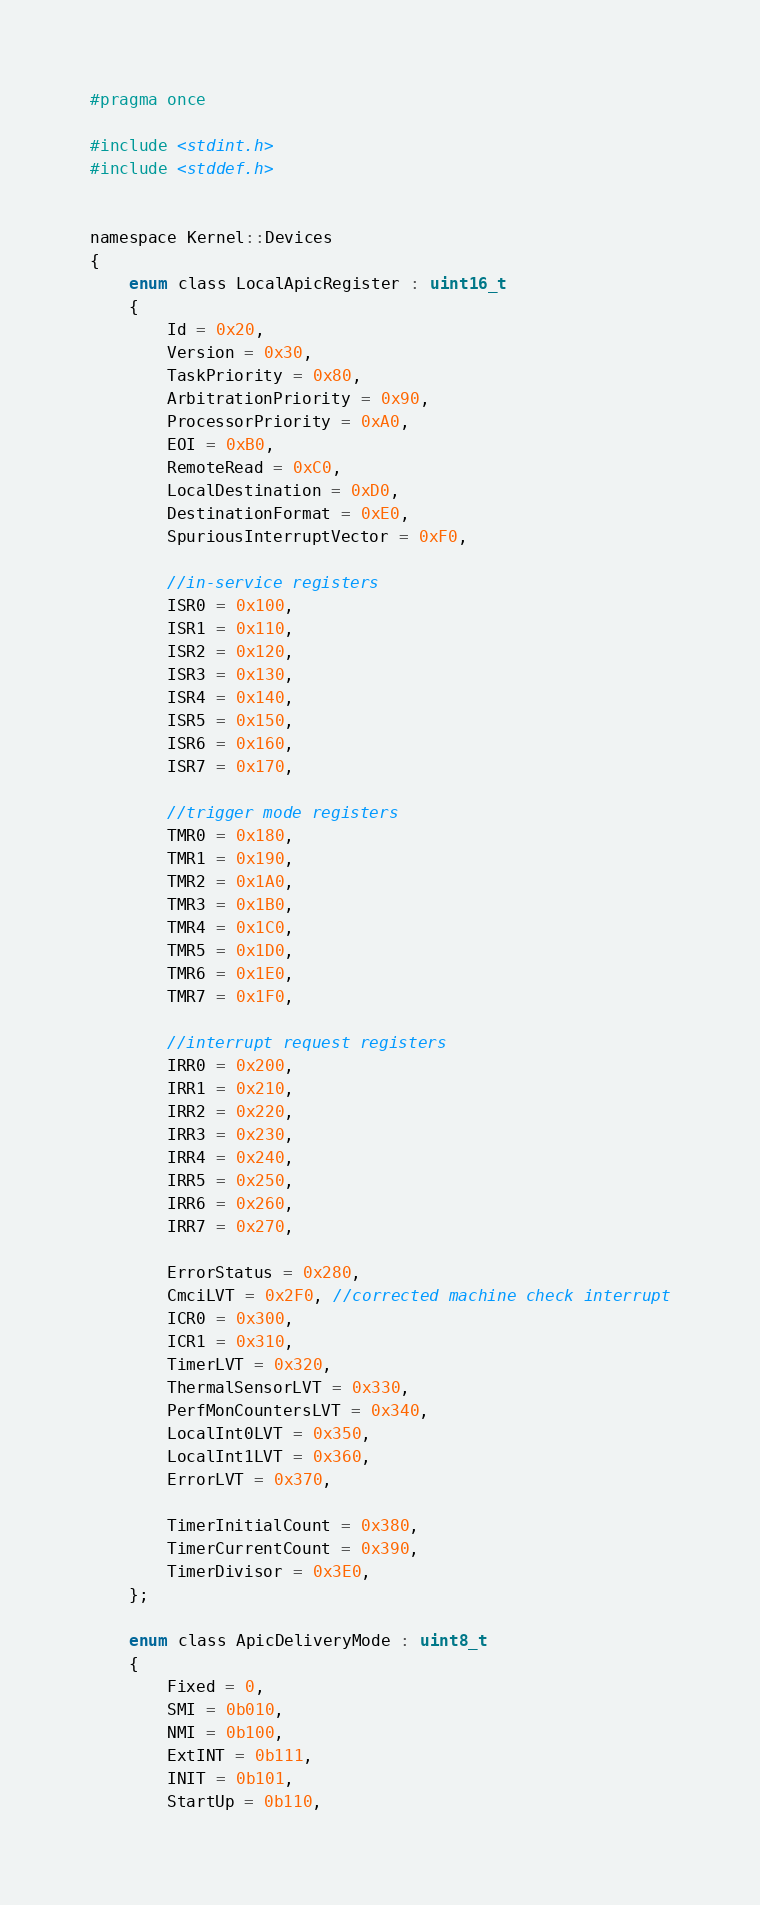Convert code to text. <code><loc_0><loc_0><loc_500><loc_500><_C_>#pragma once

#include <stdint.h>
#include <stddef.h>


namespace Kernel::Devices
{
    enum class LocalApicRegister : uint16_t
    {
        Id = 0x20,
        Version = 0x30,
        TaskPriority = 0x80,
        ArbitrationPriority = 0x90,
        ProcessorPriority = 0xA0,
        EOI = 0xB0,
        RemoteRead = 0xC0,
        LocalDestination = 0xD0,
        DestinationFormat = 0xE0,
        SpuriousInterruptVector = 0xF0,

        //in-service registers
        ISR0 = 0x100,
        ISR1 = 0x110,
        ISR2 = 0x120,
        ISR3 = 0x130,
        ISR4 = 0x140,
        ISR5 = 0x150,
        ISR6 = 0x160,
        ISR7 = 0x170,
        
        //trigger mode registers
        TMR0 = 0x180,
        TMR1 = 0x190,
        TMR2 = 0x1A0,
        TMR3 = 0x1B0,
        TMR4 = 0x1C0,
        TMR5 = 0x1D0,
        TMR6 = 0x1E0,
        TMR7 = 0x1F0,

        //interrupt request registers
        IRR0 = 0x200,
        IRR1 = 0x210,
        IRR2 = 0x220,
        IRR3 = 0x230,
        IRR4 = 0x240,
        IRR5 = 0x250,
        IRR6 = 0x260,
        IRR7 = 0x270,

        ErrorStatus = 0x280,
        CmciLVT = 0x2F0, //corrected machine check interrupt
        ICR0 = 0x300,
        ICR1 = 0x310,
        TimerLVT = 0x320,
        ThermalSensorLVT = 0x330,
        PerfMonCountersLVT = 0x340,
        LocalInt0LVT = 0x350,
        LocalInt1LVT = 0x360,
        ErrorLVT = 0x370,

        TimerInitialCount = 0x380,
        TimerCurrentCount = 0x390,
        TimerDivisor = 0x3E0,
    };

    enum class ApicDeliveryMode : uint8_t
    {
        Fixed = 0,
        SMI = 0b010,
        NMI = 0b100,
        ExtINT = 0b111,
        INIT = 0b101,
        StartUp = 0b110,</code> 